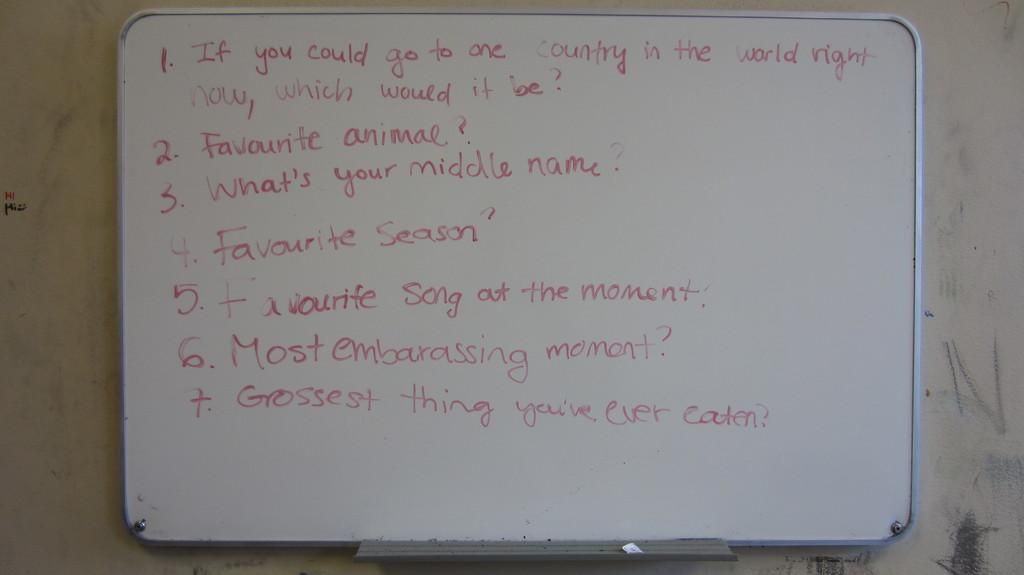<image>
Provide a brief description of the given image. A numbered list of questions, including favorite animal and most embarrassing moment, is written on a whiteboard. 